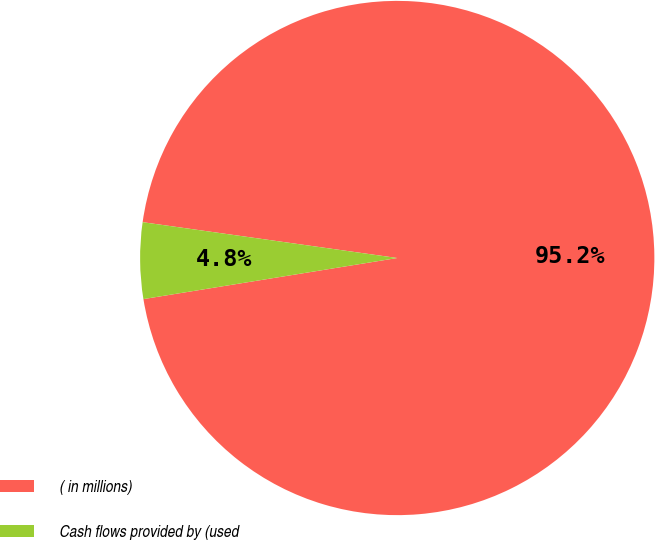<chart> <loc_0><loc_0><loc_500><loc_500><pie_chart><fcel>( in millions)<fcel>Cash flows provided by (used<nl><fcel>95.22%<fcel>4.78%<nl></chart> 